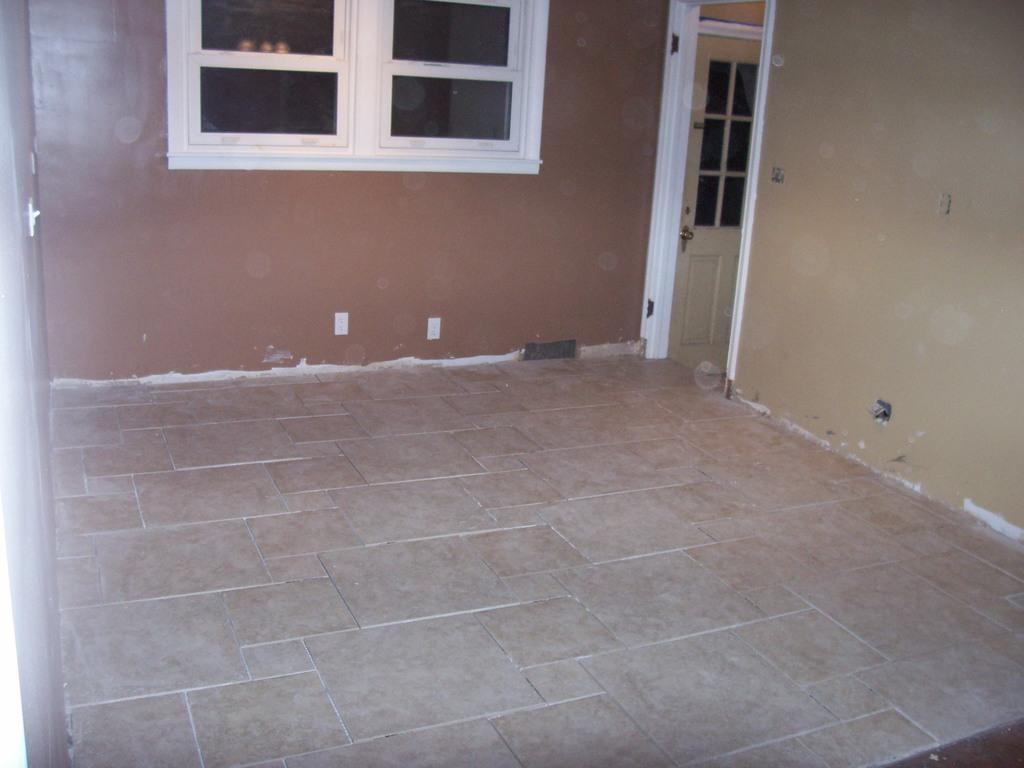What type of structure is shown in the image? The image is of a building. Where are the windows located in the building? The windows are in the center of the image. What can be used to enter or exit the building? There is a door on the right side of the image. What part of the building is visible at the bottom of the image? The bottom of the image shows the floor. What is located on the left side of the building? There is a well on the left side of the image. What type of maid is working inside the building in the image? There is no maid present in the image; it only shows the exterior of the building. What type of doctor can be seen treating patients in the well on the left side of the image? There is no doctor present in the image, and the well is not a location where a doctor would typically treat patients. 